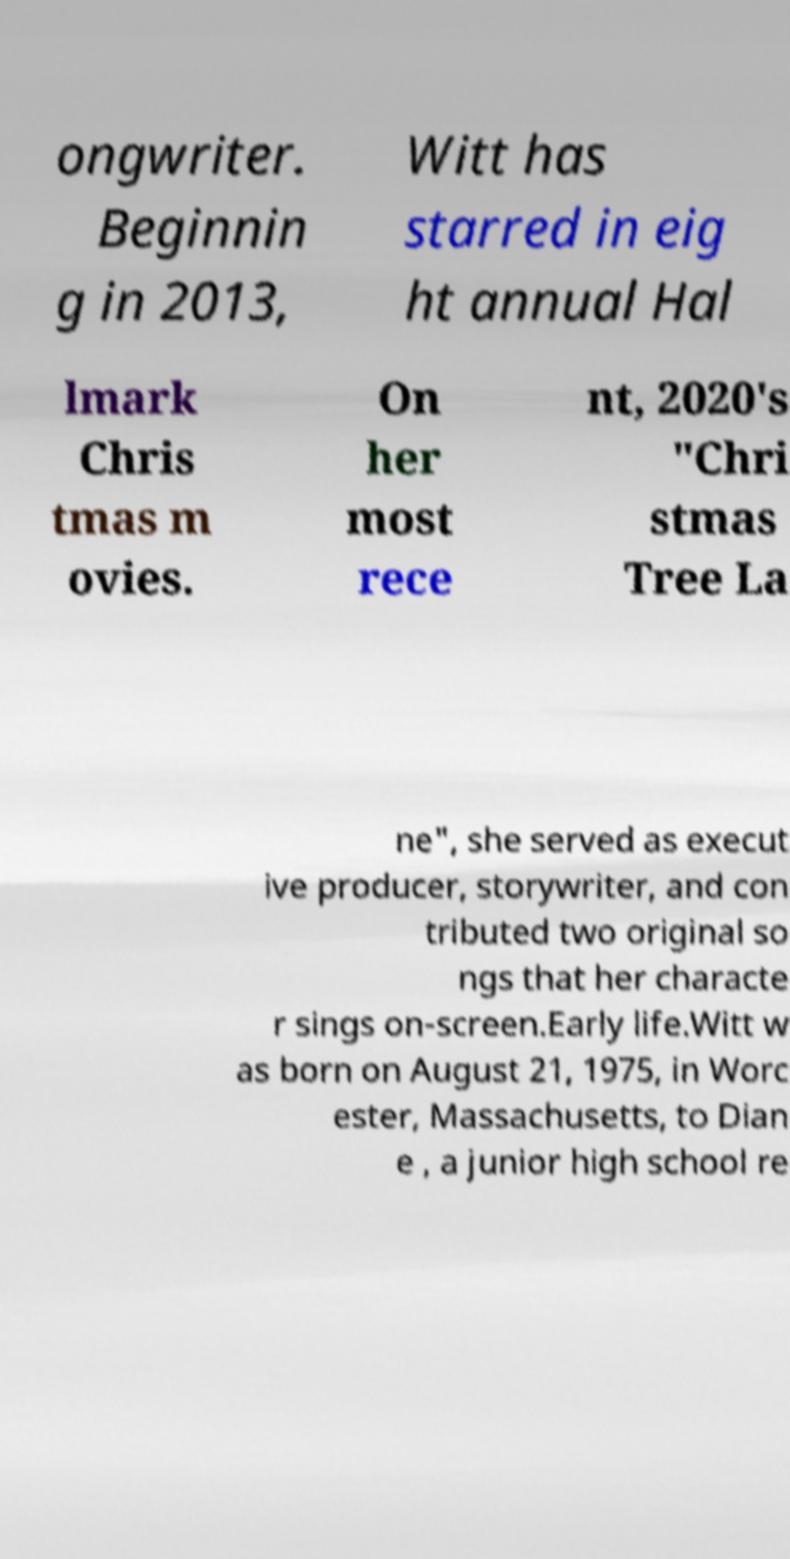Can you accurately transcribe the text from the provided image for me? ongwriter. Beginnin g in 2013, Witt has starred in eig ht annual Hal lmark Chris tmas m ovies. On her most rece nt, 2020's "Chri stmas Tree La ne", she served as execut ive producer, storywriter, and con tributed two original so ngs that her characte r sings on-screen.Early life.Witt w as born on August 21, 1975, in Worc ester, Massachusetts, to Dian e , a junior high school re 